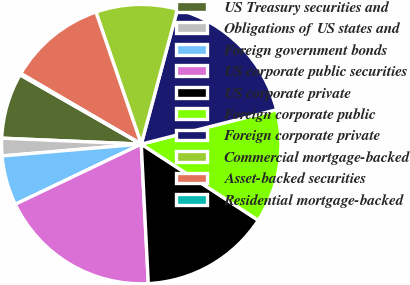Convert chart. <chart><loc_0><loc_0><loc_500><loc_500><pie_chart><fcel>US Treasury securities and<fcel>Obligations of US states and<fcel>Foreign government bonds<fcel>US corporate public securities<fcel>US corporate private<fcel>Foreign corporate public<fcel>Foreign corporate private<fcel>Commercial mortgage-backed<fcel>Asset-backed securities<fcel>Residential mortgage-backed<nl><fcel>7.59%<fcel>2.03%<fcel>5.74%<fcel>18.71%<fcel>15.01%<fcel>13.15%<fcel>16.86%<fcel>9.44%<fcel>11.3%<fcel>0.17%<nl></chart> 